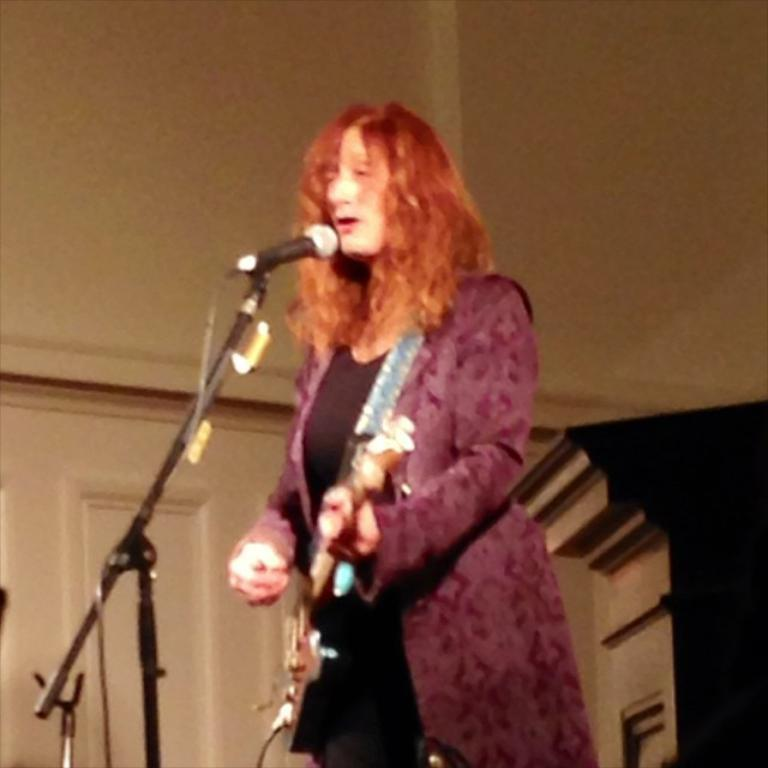Who is the main subject in the image? There is a woman in the image. What is the woman doing in the image? The woman is standing, playing a guitar, and singing into a microphone. What can be seen in the background of the image? There is a wall in the background of the image. What decision did the woman make regarding her role as a slave in the image? There is no mention of slavery or any decision-making process in the image. The woman is depicted as playing a guitar and singing into a microphone. 